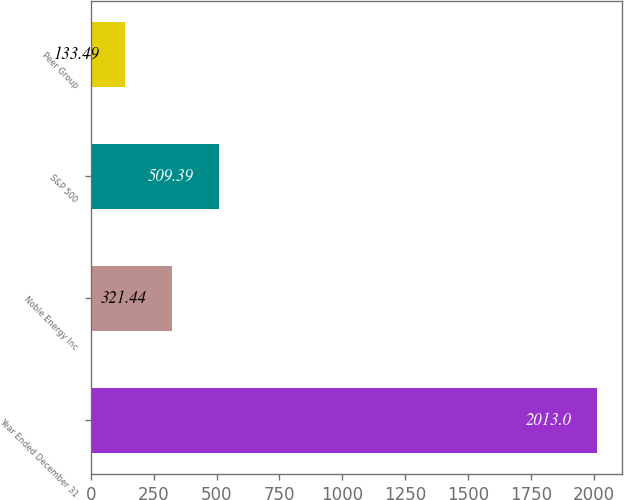Convert chart to OTSL. <chart><loc_0><loc_0><loc_500><loc_500><bar_chart><fcel>Year Ended December 31<fcel>Noble Energy Inc<fcel>S&P 500<fcel>Peer Group<nl><fcel>2013<fcel>321.44<fcel>509.39<fcel>133.49<nl></chart> 